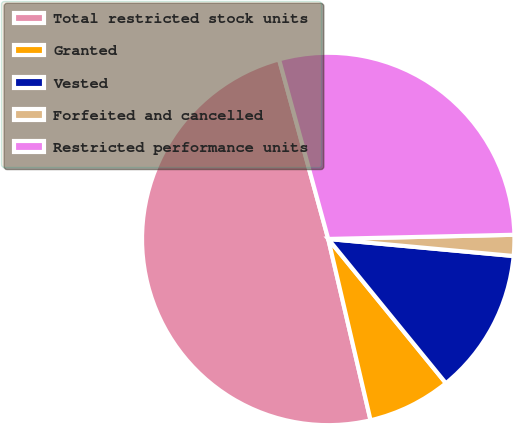Convert chart to OTSL. <chart><loc_0><loc_0><loc_500><loc_500><pie_chart><fcel>Total restricted stock units<fcel>Granted<fcel>Vested<fcel>Forfeited and cancelled<fcel>Restricted performance units<nl><fcel>49.4%<fcel>7.24%<fcel>12.65%<fcel>1.82%<fcel>28.9%<nl></chart> 